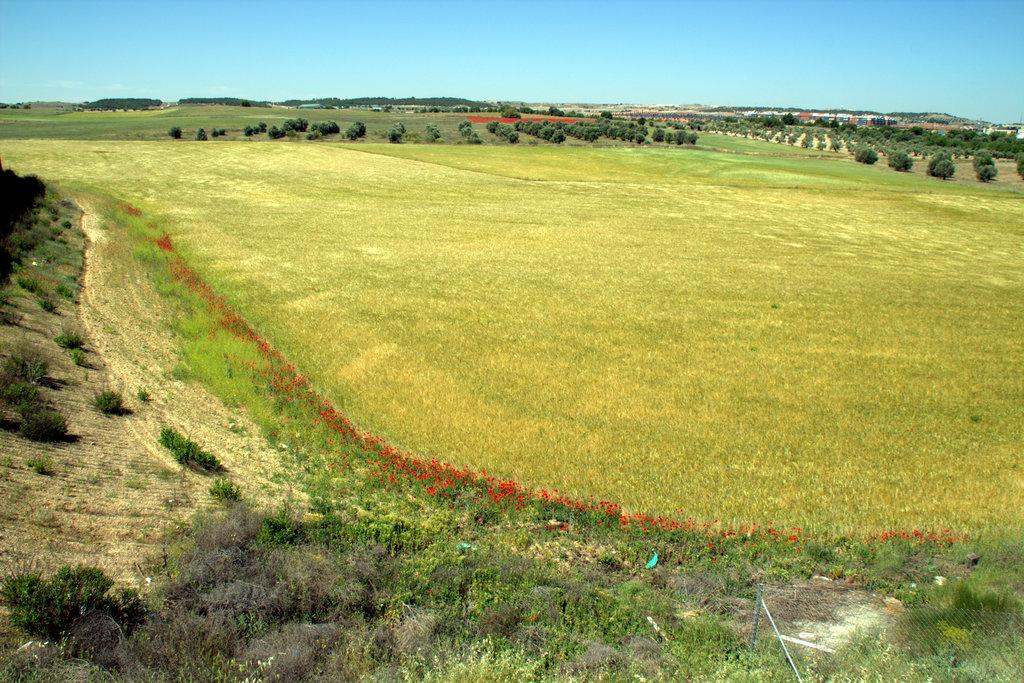What type of terrain is visible in the image? Ground is visible in the image. What type of vegetation can be seen in the image? There are shrubs and bushes in the image. What part of the natural environment is visible in the image? The sky is visible in the image. What type of punishment is being given to the person in the image? There is no person present in the image, and therefore no punishment can be observed. 